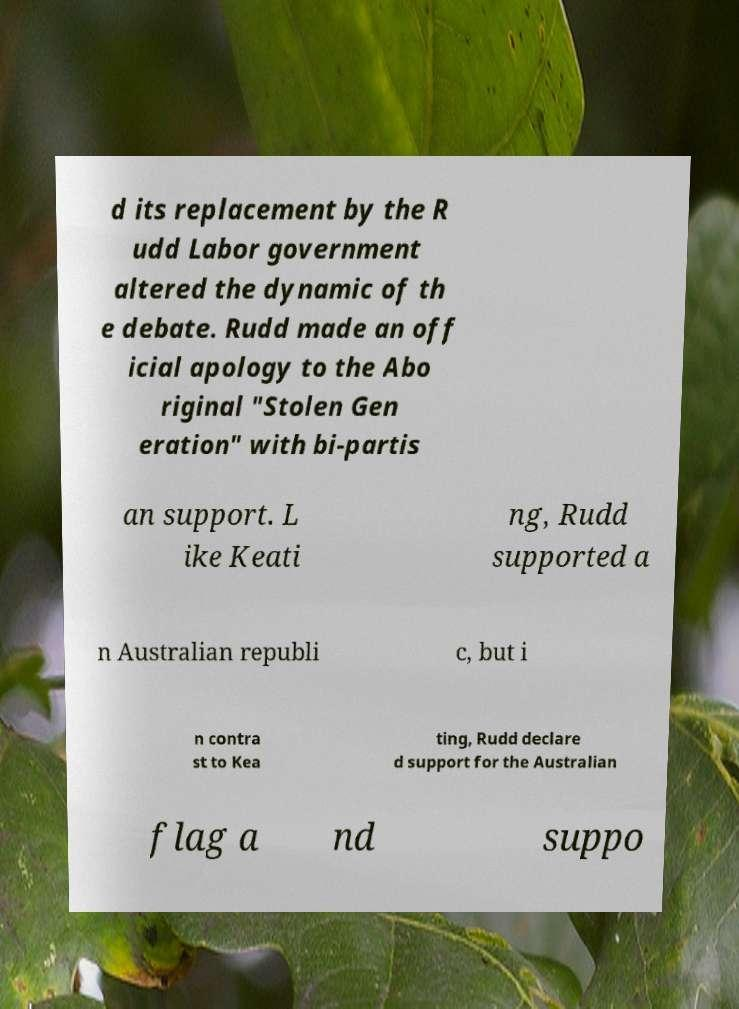There's text embedded in this image that I need extracted. Can you transcribe it verbatim? d its replacement by the R udd Labor government altered the dynamic of th e debate. Rudd made an off icial apology to the Abo riginal "Stolen Gen eration" with bi-partis an support. L ike Keati ng, Rudd supported a n Australian republi c, but i n contra st to Kea ting, Rudd declare d support for the Australian flag a nd suppo 